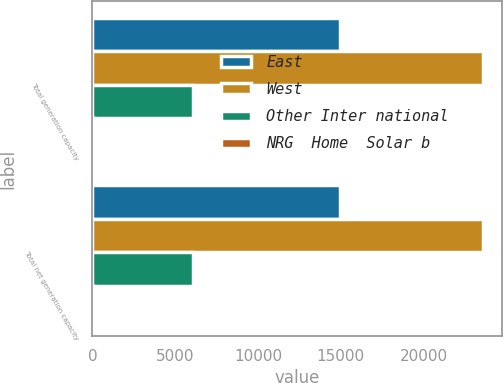Convert chart. <chart><loc_0><loc_0><loc_500><loc_500><stacked_bar_chart><ecel><fcel>Total generation capacity<fcel>Total net generation capacity<nl><fcel>East<fcel>14941<fcel>14941<nl><fcel>West<fcel>23579<fcel>23579<nl><fcel>Other Inter national<fcel>6085<fcel>6085<nl><fcel>NRG  Home  Solar b<fcel>93<fcel>93<nl></chart> 